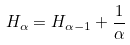Convert formula to latex. <formula><loc_0><loc_0><loc_500><loc_500>H _ { \alpha } = H _ { \alpha - 1 } + \frac { 1 } { \alpha }</formula> 